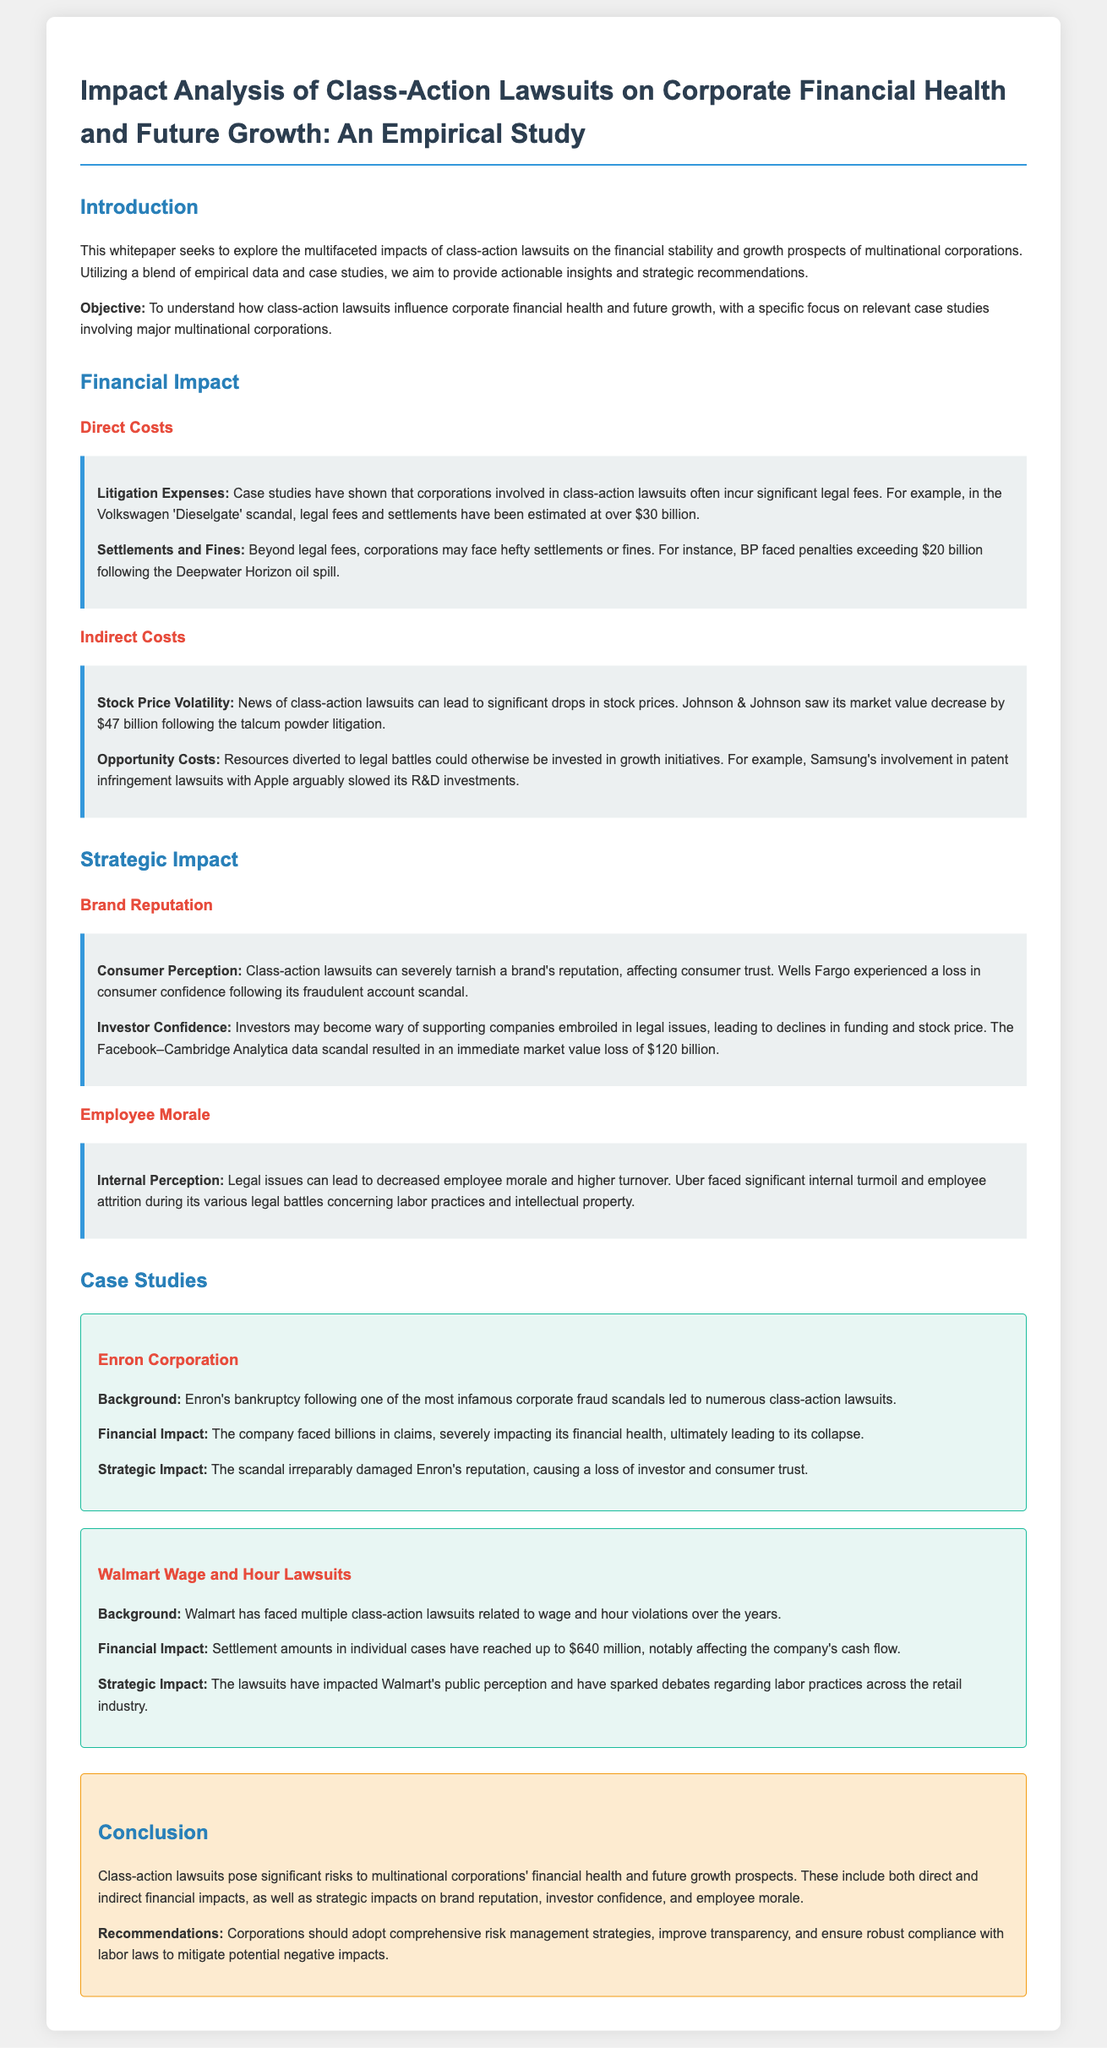What is the main objective of the whitepaper? The objective is to understand how class-action lawsuits influence corporate financial health and future growth.
Answer: To understand how class-action lawsuits influence corporate financial health and future growth What was the legal expense for Volkswagen in the Dieselgate scandal? The document states that legal fees and settlements for Volkswagen were estimated at over $30 billion.
Answer: over $30 billion What impact did the talcum powder litigation have on Johnson & Johnson's market value? The document indicates that Johnson & Johnson's market value decreased by $47 billion following the litigation.
Answer: $47 billion What was the financial penalty BP faced after the Deepwater Horizon oil spill? The whitepaper notes that BP faced penalties exceeding $20 billion.
Answer: exceeding $20 billion What happened to Wells Fargo's consumer confidence after its scandal? The document mentions that Wells Fargo experienced a loss in consumer confidence following its fraudulent account scandal.
Answer: loss in consumer confidence Which corporation faced multiple class-action lawsuits related to wage and hour violations? The document specifies that Walmart has faced multiple class-action lawsuits regarding wage and hour violations.
Answer: Walmart What significant market value loss did Facebook incur due to the Cambridge Analytica scandal? The document states that Facebook experienced an immediate market value loss of $120 billion.
Answer: $120 billion What are two key recommendations for corporations to mitigate risks from lawsuits? The whitepaper recommends adopting comprehensive risk management strategies and improving transparency.
Answer: comprehensive risk management strategies and improving transparency How did Enron's legal issues affect its overall reputation? The document indicates that Enron's scandal caused a loss of investor and consumer trust, damaging its reputation.
Answer: loss of investor and consumer trust 